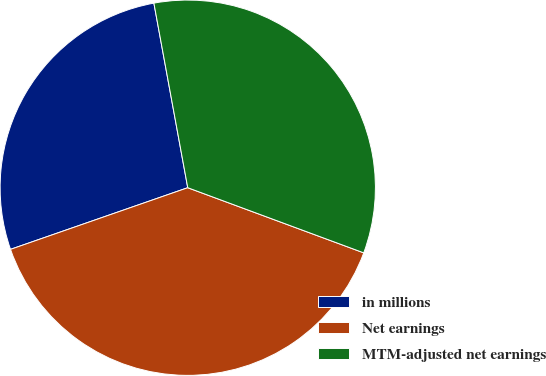Convert chart. <chart><loc_0><loc_0><loc_500><loc_500><pie_chart><fcel>in millions<fcel>Net earnings<fcel>MTM-adjusted net earnings<nl><fcel>27.44%<fcel>39.03%<fcel>33.53%<nl></chart> 